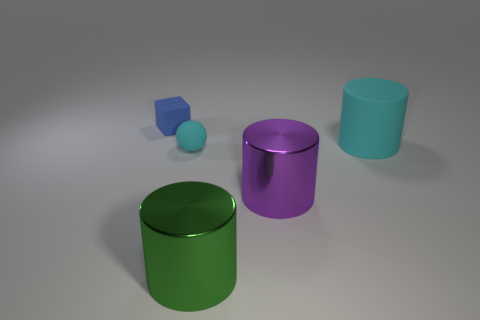What is the shape of the blue matte object that is the same size as the matte sphere?
Provide a succinct answer. Cube. Are there any balls to the right of the blue thing?
Your answer should be very brief. Yes. Is the small thing that is on the right side of the block made of the same material as the thing that is behind the big matte object?
Ensure brevity in your answer.  Yes. What number of blue objects have the same size as the cube?
Your answer should be very brief. 0. There is another thing that is the same color as the large matte object; what is its shape?
Make the answer very short. Sphere. There is a big purple object behind the big green shiny object; what is it made of?
Ensure brevity in your answer.  Metal. How many large green things are the same shape as the tiny blue thing?
Give a very brief answer. 0. What is the shape of the blue object that is made of the same material as the large cyan thing?
Ensure brevity in your answer.  Cube. What shape is the small object in front of the matte thing that is right of the large cylinder that is to the left of the purple metallic object?
Your response must be concise. Sphere. Are there more large gray metal balls than tiny rubber balls?
Make the answer very short. No. 